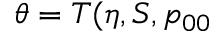Convert formula to latex. <formula><loc_0><loc_0><loc_500><loc_500>\theta = T ( \eta , S , p _ { 0 0 }</formula> 